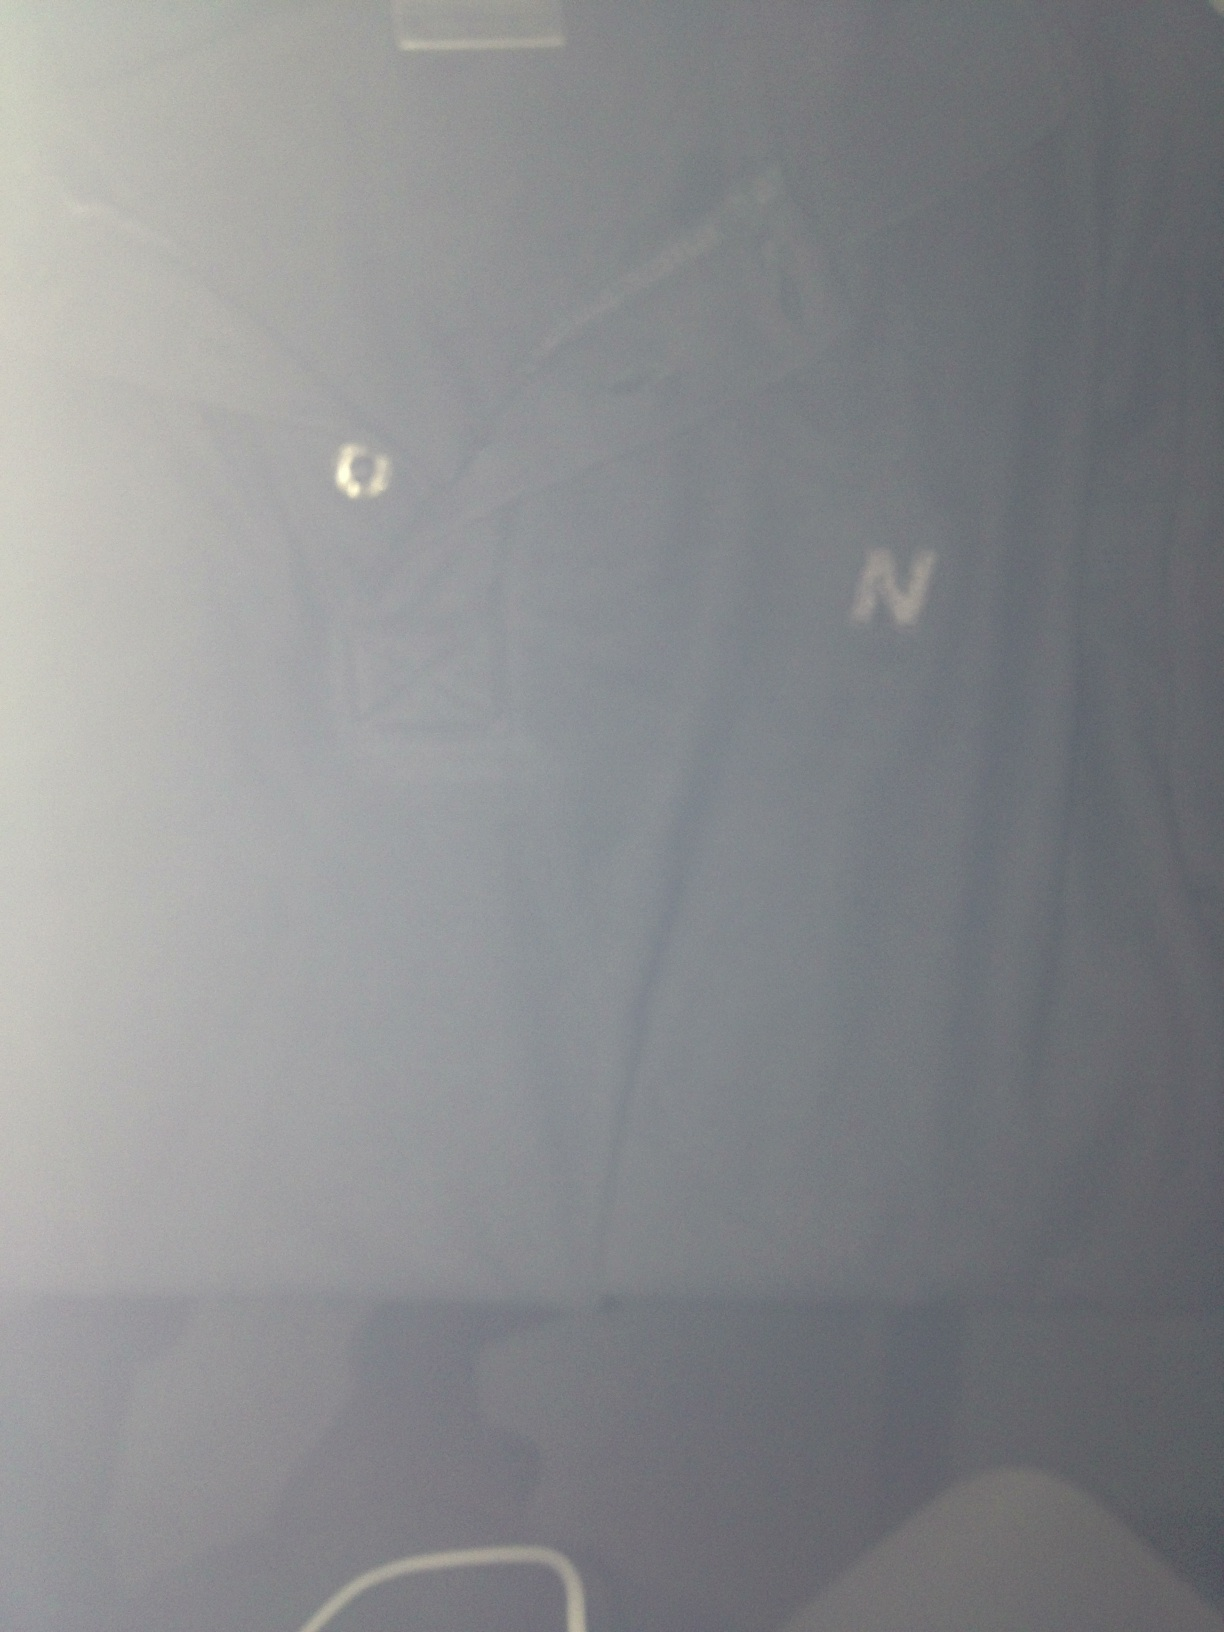Imagine if this tee shirt could talk. What stories would it share about its owner? If this tee shirt could talk, it would tell tales of countless adventures and experiences. It would recount the time it was worn during an impromptu road trip with friends, or the rainy day it kept its owner dry while they watched their favorite band perform live. It would share memories of cozy evenings spent at home, the satisfaction of completing a challenging hike, and the pride of being the chosen outfit for a family reunion. Each wrinkle and faded spot would be a testament to the vibrant, lived-in life of its owner. 